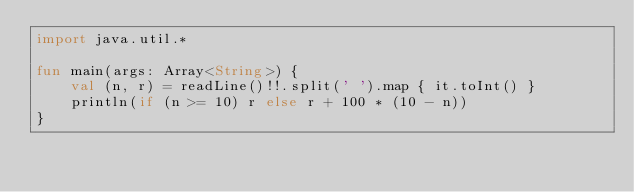<code> <loc_0><loc_0><loc_500><loc_500><_Kotlin_>import java.util.*

fun main(args: Array<String>) {
    val (n, r) = readLine()!!.split(' ').map { it.toInt() }
    println(if (n >= 10) r else r + 100 * (10 - n))
}</code> 